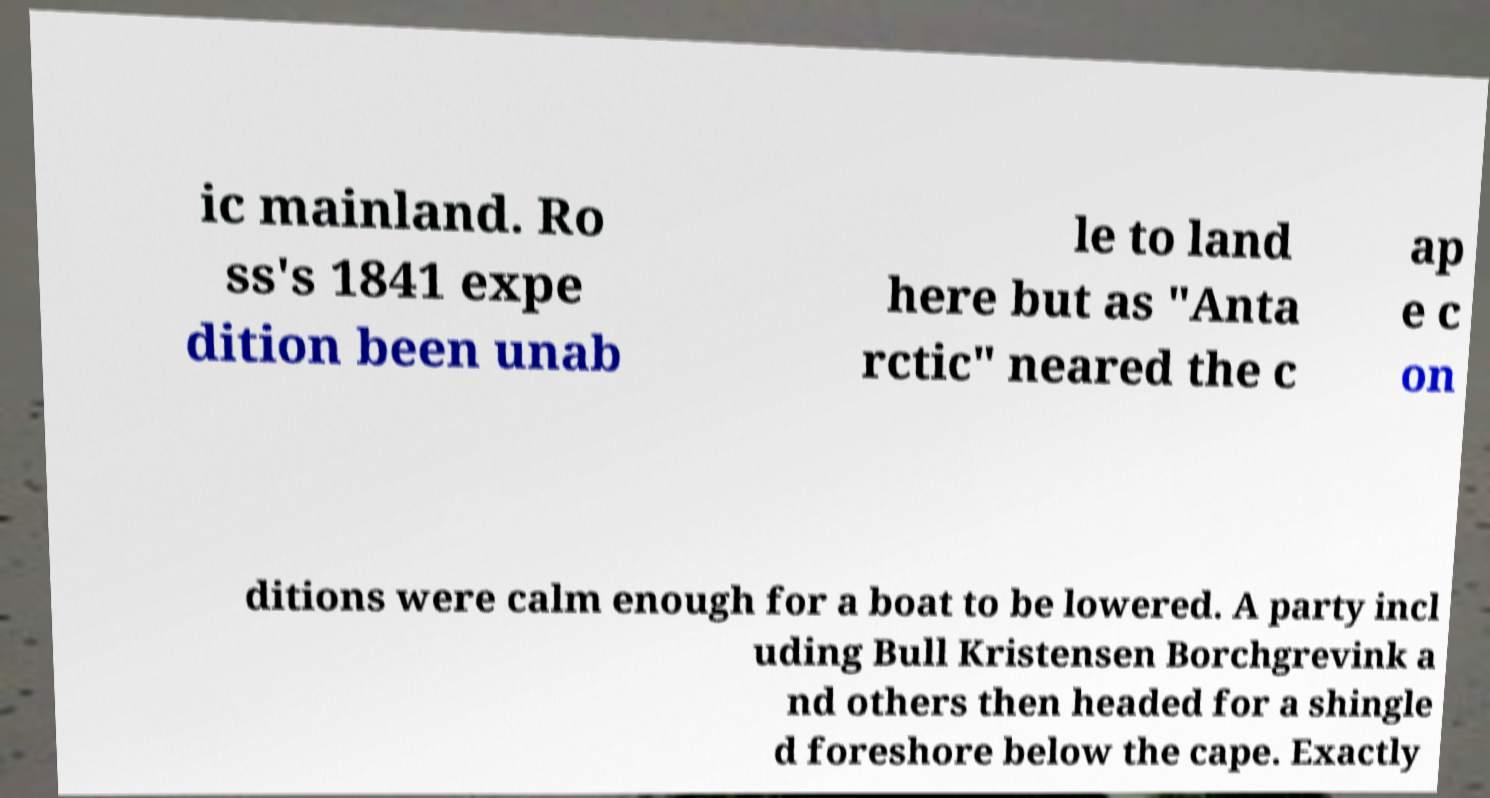I need the written content from this picture converted into text. Can you do that? ic mainland. Ro ss's 1841 expe dition been unab le to land here but as "Anta rctic" neared the c ap e c on ditions were calm enough for a boat to be lowered. A party incl uding Bull Kristensen Borchgrevink a nd others then headed for a shingle d foreshore below the cape. Exactly 